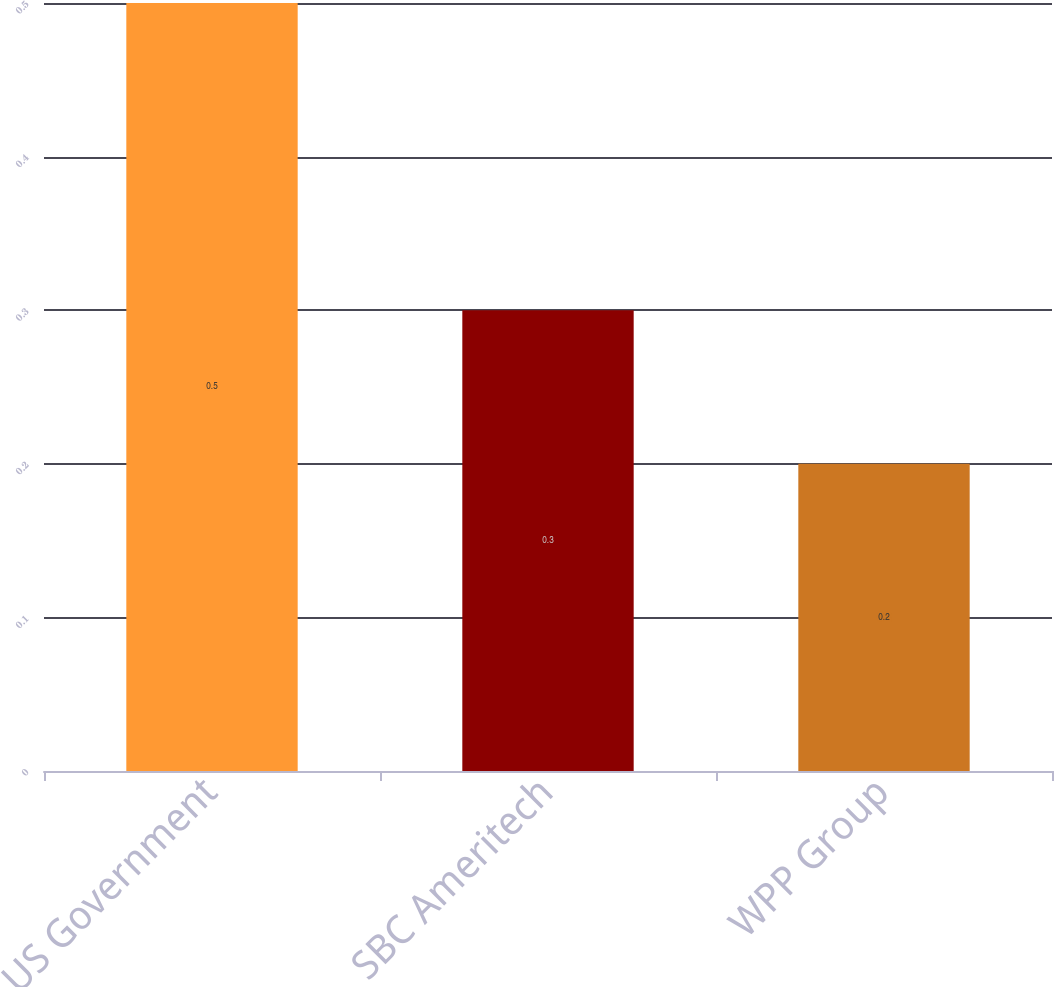Convert chart to OTSL. <chart><loc_0><loc_0><loc_500><loc_500><bar_chart><fcel>US Government<fcel>SBC Ameritech<fcel>WPP Group<nl><fcel>0.5<fcel>0.3<fcel>0.2<nl></chart> 